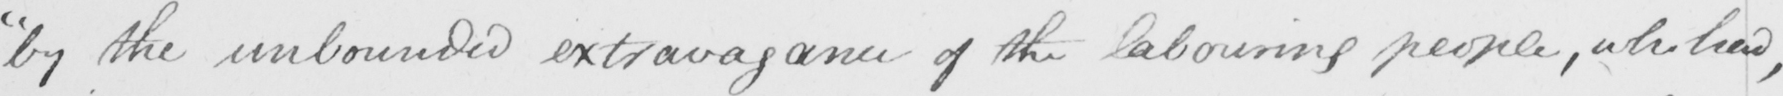What does this handwritten line say? " by the unbounded extravagance of the labouring people , who had , 